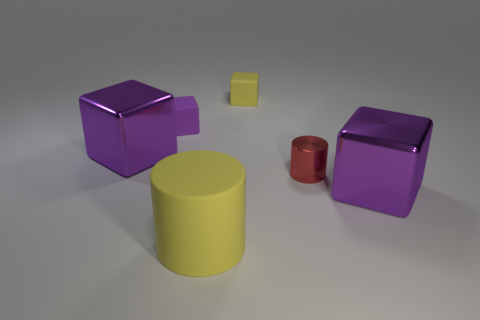Subtract all purple cubes. How many were subtracted if there are1purple cubes left? 2 Subtract all purple rubber blocks. How many blocks are left? 3 Subtract all red cylinders. How many cylinders are left? 1 Subtract all green balls. How many purple cubes are left? 3 Add 3 yellow metal balls. How many objects exist? 9 Subtract all cylinders. How many objects are left? 4 Subtract 2 cylinders. How many cylinders are left? 0 Subtract 2 purple blocks. How many objects are left? 4 Subtract all gray cubes. Subtract all red spheres. How many cubes are left? 4 Subtract all big matte cylinders. Subtract all big cylinders. How many objects are left? 4 